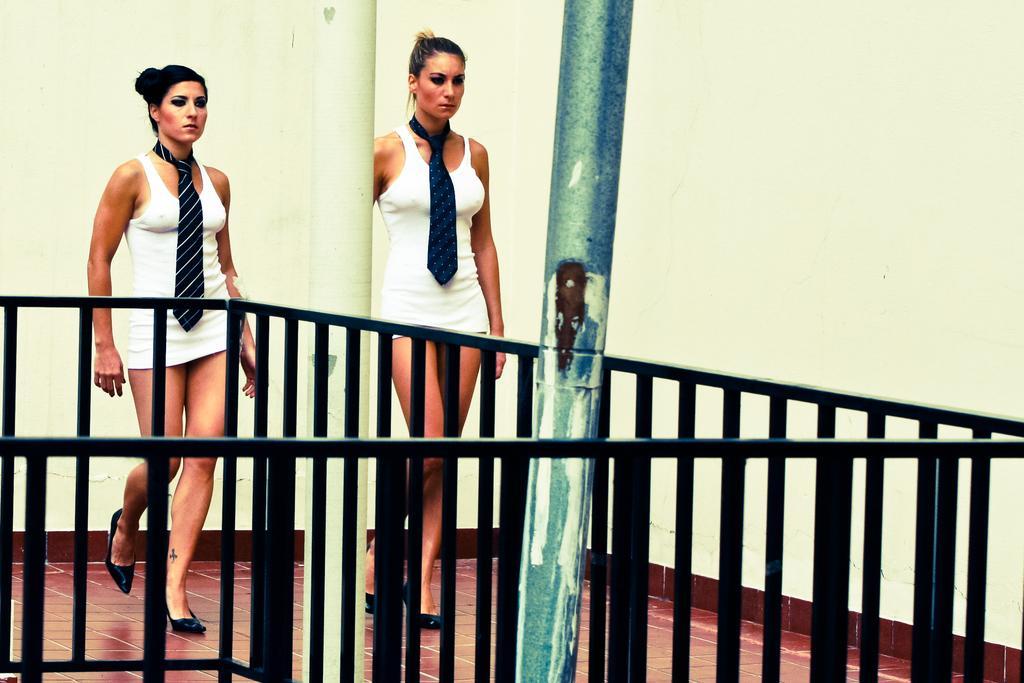Can you describe this image briefly? This image is taken indoors. In the background there is a wall. In the middle of the image two women are walking on the floor. There is a pillar. There is a railing and there is a pole. 